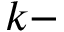<formula> <loc_0><loc_0><loc_500><loc_500>k -</formula> 